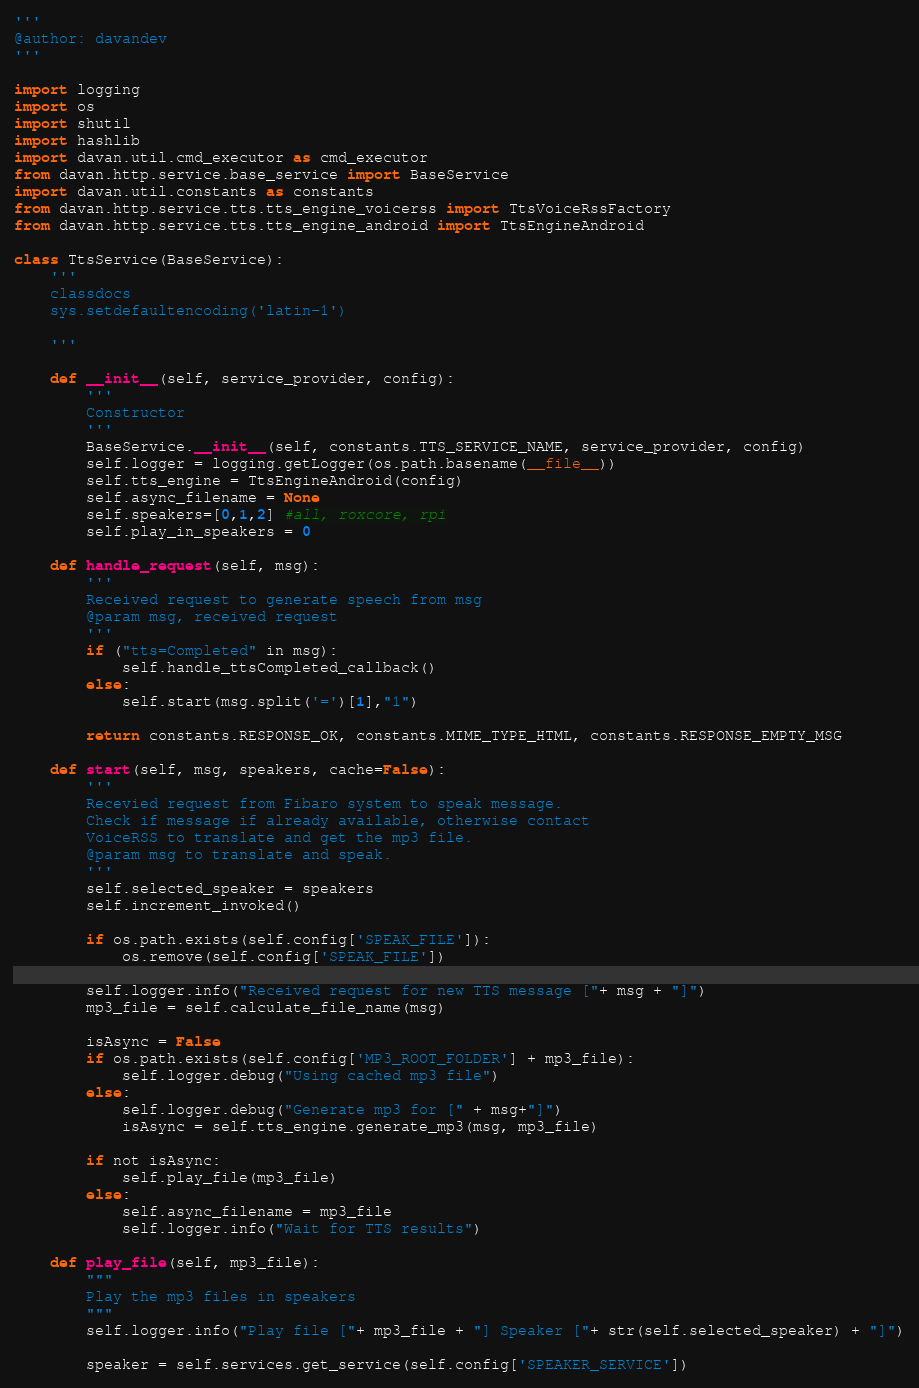<code> <loc_0><loc_0><loc_500><loc_500><_Python_>'''
@author: davandev
'''
 
import logging
import os
import shutil
import hashlib
import davan.util.cmd_executor as cmd_executor
from davan.http.service.base_service import BaseService
import davan.util.constants as constants 
from davan.http.service.tts.tts_engine_voicerss import TtsVoiceRssFactory 
from davan.http.service.tts.tts_engine_android import TtsEngineAndroid

class TtsService(BaseService):
    '''
    classdocs
    sys.setdefaultencoding('latin-1')

    '''

    def __init__(self, service_provider, config):
        '''
        Constructor
        '''
        BaseService.__init__(self, constants.TTS_SERVICE_NAME, service_provider, config)
        self.logger = logging.getLogger(os.path.basename(__file__))
        self.tts_engine = TtsEngineAndroid(config)
        self.async_filename = None
        self.speakers=[0,1,2] #all, roxcore, rpi
        self.play_in_speakers = 0
        
    def handle_request(self, msg):
        '''
        Received request to generate speech from msg
        @param msg, received request 
        '''
        if ("tts=Completed" in msg):
            self.handle_ttsCompleted_callback()
        else:
            self.start(msg.split('=')[1],"1")

        return constants.RESPONSE_OK, constants.MIME_TYPE_HTML, constants.RESPONSE_EMPTY_MSG
    
    def start(self, msg, speakers, cache=False):
        '''
        Recevied request from Fibaro system to speak message.
        Check if message if already available, otherwise contact
        VoiceRSS to translate and get the mp3 file.
        @param msg to translate and speak.
        '''
        self.selected_speaker = speakers
        self.increment_invoked()

        if os.path.exists(self.config['SPEAK_FILE']):
            os.remove(self.config['SPEAK_FILE'])

        self.logger.info("Received request for new TTS message ["+ msg + "]")
        mp3_file = self.calculate_file_name(msg)
        
        isAsync = False
        if os.path.exists(self.config['MP3_ROOT_FOLDER'] + mp3_file):
            self.logger.debug("Using cached mp3 file")
        else:   
            self.logger.debug("Generate mp3 for [" + msg+"]")
            isAsync = self.tts_engine.generate_mp3(msg, mp3_file)
        
        if not isAsync:
            self.play_file(mp3_file)
        else:
            self.async_filename = mp3_file
            self.logger.info("Wait for TTS results")
                    
    def play_file(self, mp3_file):
        """
        Play the mp3 files in speakers
        """
        self.logger.info("Play file ["+ mp3_file + "] Speaker ["+ str(self.selected_speaker) + "]")
        
        speaker = self.services.get_service(self.config['SPEAKER_SERVICE'])</code> 